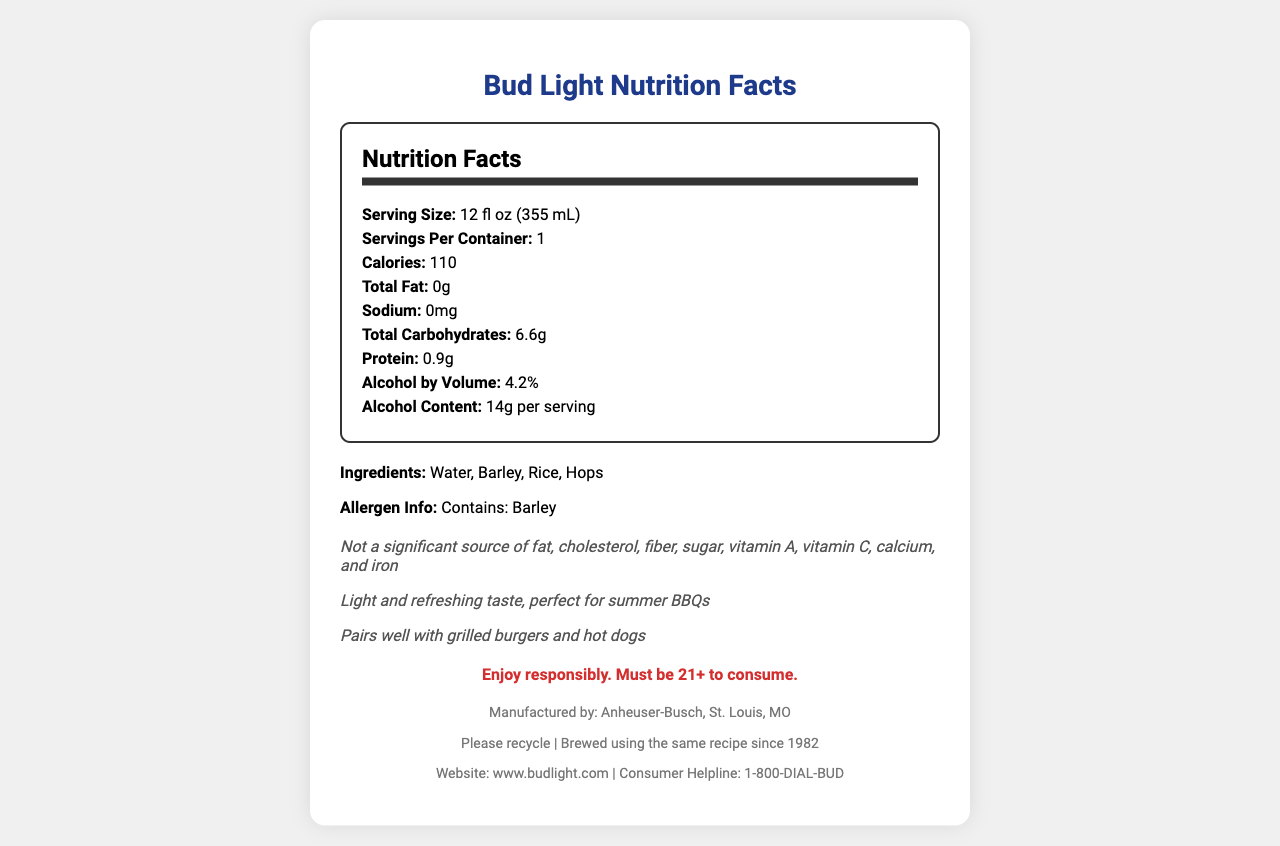what is the serving size for Bud Light? The serving size is explicitly listed as 12 fl oz (355 mL) in the nutrition facts.
Answer: 12 fl oz (355 mL) how many calories are there per serving? The document lists the calorie content as 110 per serving.
Answer: 110 what are the total carbohydrates in a serving of Bud Light? The total carbohydrates per serving are listed as 6.6g.
Answer: 6.6g is there any sodium in a serving of Bud Light? The sodium content is listed as 0mg in the nutrition facts.
Answer: No what ingredients are used in Bud Light? The ingredients section lists water, barley, rice, and hops.
Answer: Water, Barley, Rice, Hops what is the alcohol by volume percentage for Bud Light? The nutrition facts show that the alcohol by volume is 4.2%.
Answer: 4.2% what is the alcohol content per serving? The document states that the alcohol content is 14g per serving.
Answer: 14g per serving which location manufactures Bud Light? The footer of the document mentions that Bud Light is manufactured by Anheuser-Busch in St. Louis, MO.
Answer: Anheuser-Busch, St. Louis, MO what allergen information is provided for Bud Light? The allergen information reveals that Bud Light contains barley.
Answer: Contains: Barley what is not a significant source found in Bud Light? The additional facts section states that Bud Light is not a significant source of these nutrients.
Answer: Fat, cholesterol, fiber, sugar, vitamin A, vitamin C, calcium, and iron when was the brewing tradition for Bud Light established? The document mentions that Bud Light has been brewed using the same recipe since 1982.
Answer: 1982 how many grams of protein are in a serving of Bud Light? The protein content per serving is listed as 0.9g.
Answer: 0.9g what message is given regarding responsible drinking? The responsible drinking message states to enjoy responsibly and notes that consumers must be 21 or older.
Answer: Enjoy responsibly. Must be 21+ to consume. which of the following is a correct fact about Bud Light? A. Contains sugar B. Has 200 calories C. Light and refreshing taste Option C is correct, as the document mentions Bud Light has a light and refreshing taste.
Answer: C. Light and refreshing taste what type of container should Bud Light be recycled in? The footer of the document includes the recycling information that states "Please recycle."
Answer: Please recycle does Bud Light contain any fat? The total fat content is listed as 0g, meaning Bud Light does not contain any fat.
Answer: No describe the main idea of the Bud Light nutrition facts document. The document is a comprehensive nutrition facts label that includes details like serving size, nutrients, ingredients, and additional claims about the taste and suitability for BBQs, enhancing consumer awareness.
Answer: The document provides detailed nutritional information about Bud Light, including serving size, calorie count, and ingredients. It highlights the light and refreshing nature of the beer, mentions that it pairs well with BBQ food, and provides responsible drinking messages. what was the revenue of Bud Light last year? The document does not provide any financial information, such as revenue or sales data.
Answer: Cannot be determined 